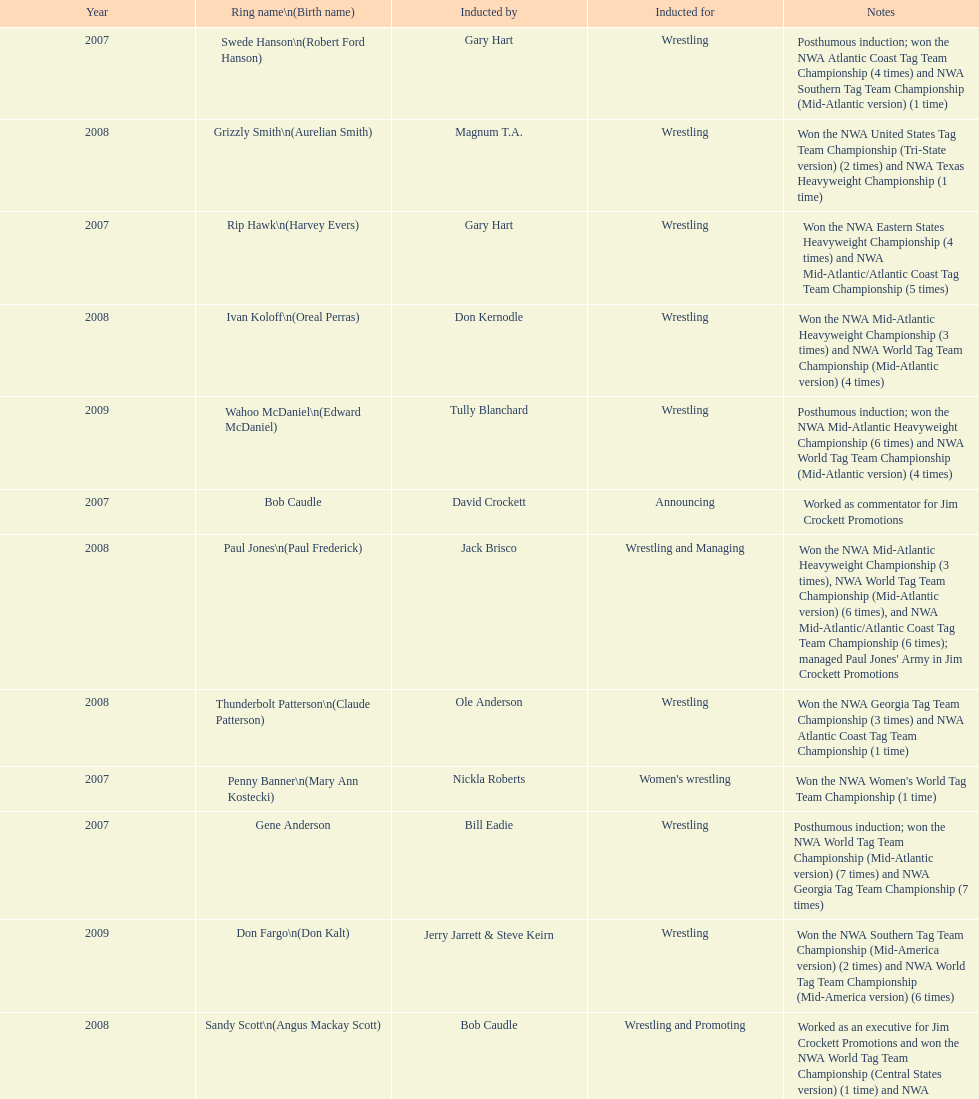Inform me about an inductee who was deceased at the moment. Gene Anderson. 